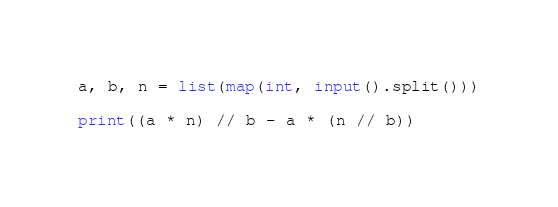<code> <loc_0><loc_0><loc_500><loc_500><_Python_>a, b, n = list(map(int, input().split()))

print((a * n) // b - a * (n // b))</code> 